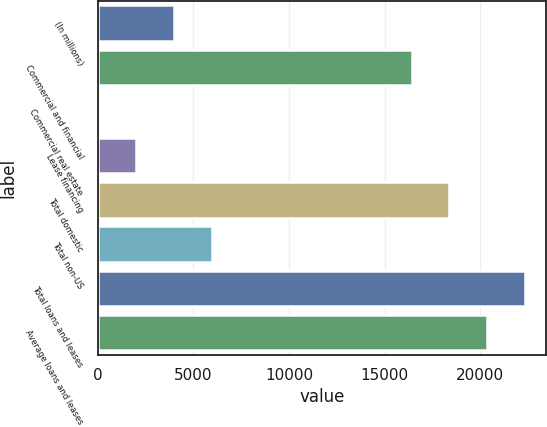Convert chart to OTSL. <chart><loc_0><loc_0><loc_500><loc_500><bar_chart><fcel>(In millions)<fcel>Commercial and financial<fcel>Commercial real estate<fcel>Lease financing<fcel>Total domestic<fcel>Total non-US<fcel>Total loans and leases<fcel>Average loans and leases<nl><fcel>3973<fcel>16412<fcel>27<fcel>2000<fcel>18385<fcel>5946<fcel>22331<fcel>20358<nl></chart> 